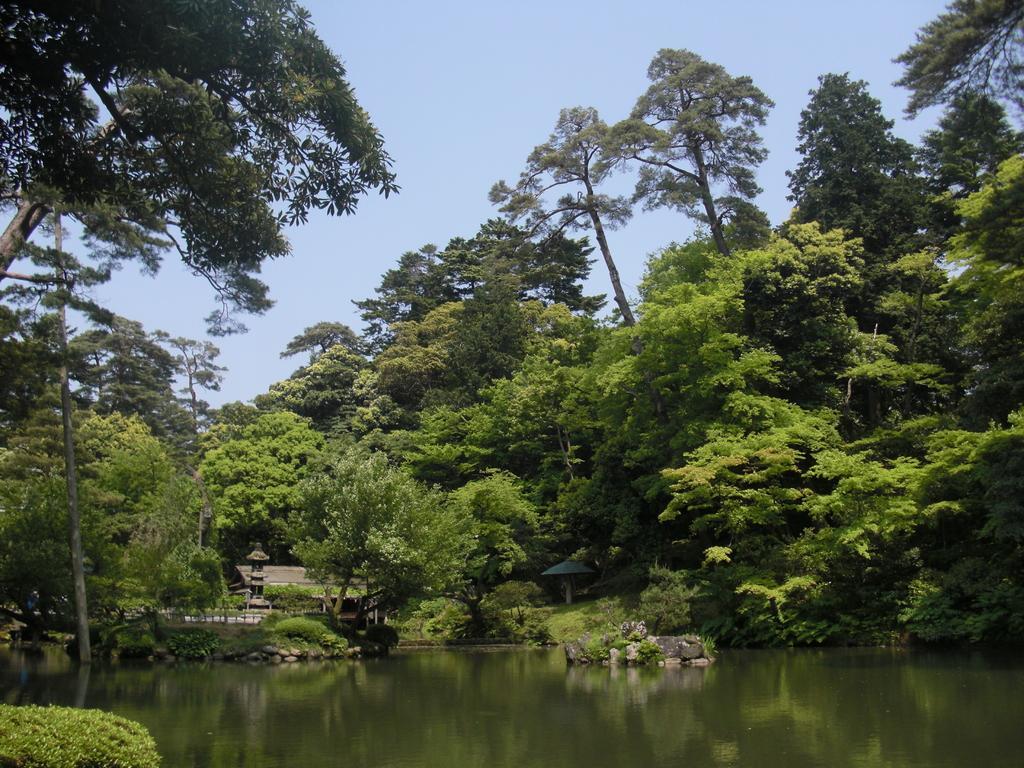Can you describe this image briefly? In this image we can see trees. At the top of the image, we can see the sky. At the bottom of the image, we can see water. There is a plant in the left bottom of the image. We can see an umbrella in the middle of the image. 